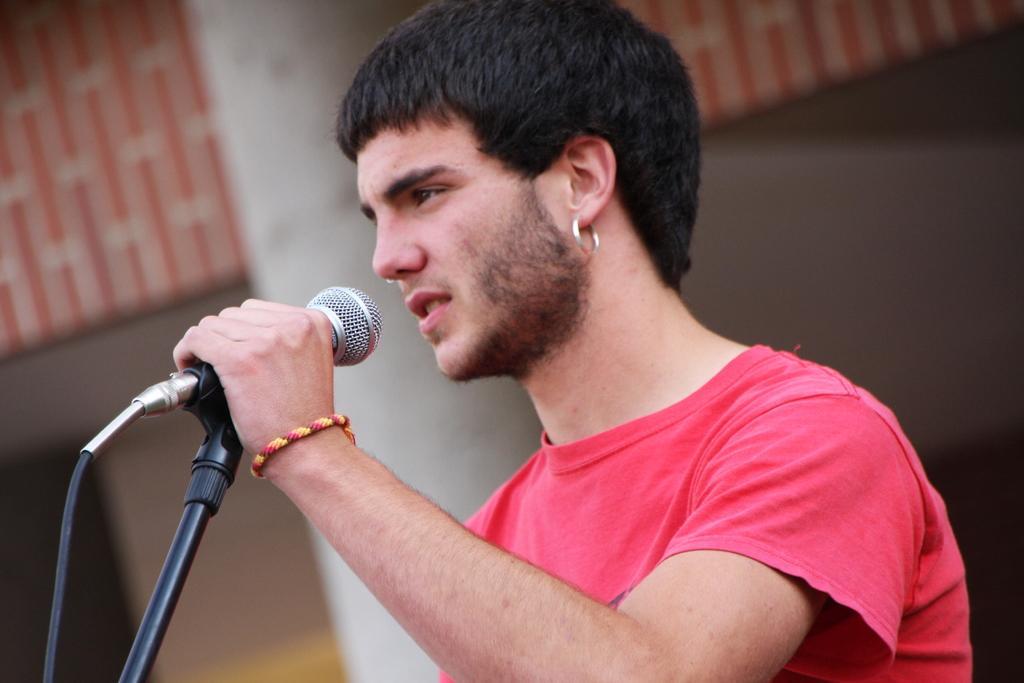Can you describe this image briefly? As we can see in the image there is a man holding mic. 